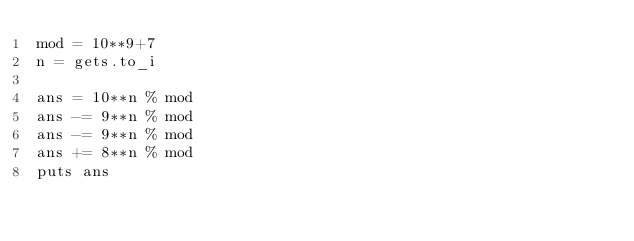Convert code to text. <code><loc_0><loc_0><loc_500><loc_500><_Ruby_>mod = 10**9+7
n = gets.to_i

ans = 10**n % mod
ans -= 9**n % mod
ans -= 9**n % mod
ans += 8**n % mod
puts ans</code> 